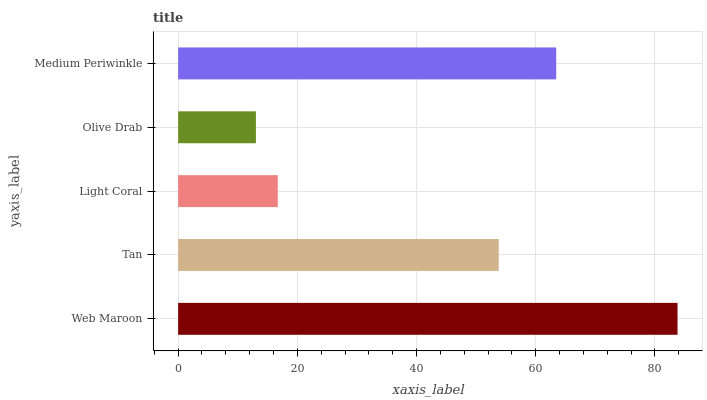Is Olive Drab the minimum?
Answer yes or no. Yes. Is Web Maroon the maximum?
Answer yes or no. Yes. Is Tan the minimum?
Answer yes or no. No. Is Tan the maximum?
Answer yes or no. No. Is Web Maroon greater than Tan?
Answer yes or no. Yes. Is Tan less than Web Maroon?
Answer yes or no. Yes. Is Tan greater than Web Maroon?
Answer yes or no. No. Is Web Maroon less than Tan?
Answer yes or no. No. Is Tan the high median?
Answer yes or no. Yes. Is Tan the low median?
Answer yes or no. Yes. Is Web Maroon the high median?
Answer yes or no. No. Is Light Coral the low median?
Answer yes or no. No. 